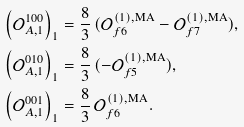<formula> <loc_0><loc_0><loc_500><loc_500>\left ( \mathcal { O } ^ { 1 0 0 } _ { A , 1 } \right ) _ { 1 } & = \frac { 8 } { 3 } \, ( \mathcal { O } _ { f 6 } ^ { ( 1 ) , \text {MA} } - \mathcal { O } _ { f 7 } ^ { ( 1 ) , \text {MA} } ) , \\ \left ( \mathcal { O } ^ { 0 1 0 } _ { A , 1 } \right ) _ { 1 } & = \frac { 8 } { 3 } \, ( - \mathcal { O } _ { f 5 } ^ { ( 1 ) , \text {MA} } ) , \\ \left ( \mathcal { O } ^ { 0 0 1 } _ { A , 1 } \right ) _ { 1 } & = \frac { 8 } { 3 } \, \mathcal { O } _ { f 6 } ^ { ( 1 ) , \text {MA} } .</formula> 